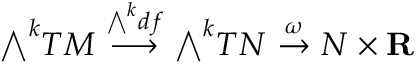Convert formula to latex. <formula><loc_0><loc_0><loc_500><loc_500>{ \bigwedge } ^ { k } T M \ { \stackrel { { \bigwedge } ^ { k } d f } { \longrightarrow } } \ { \bigwedge } ^ { k } T N \ { \stackrel { \omega } { \to } } \ N \times R</formula> 